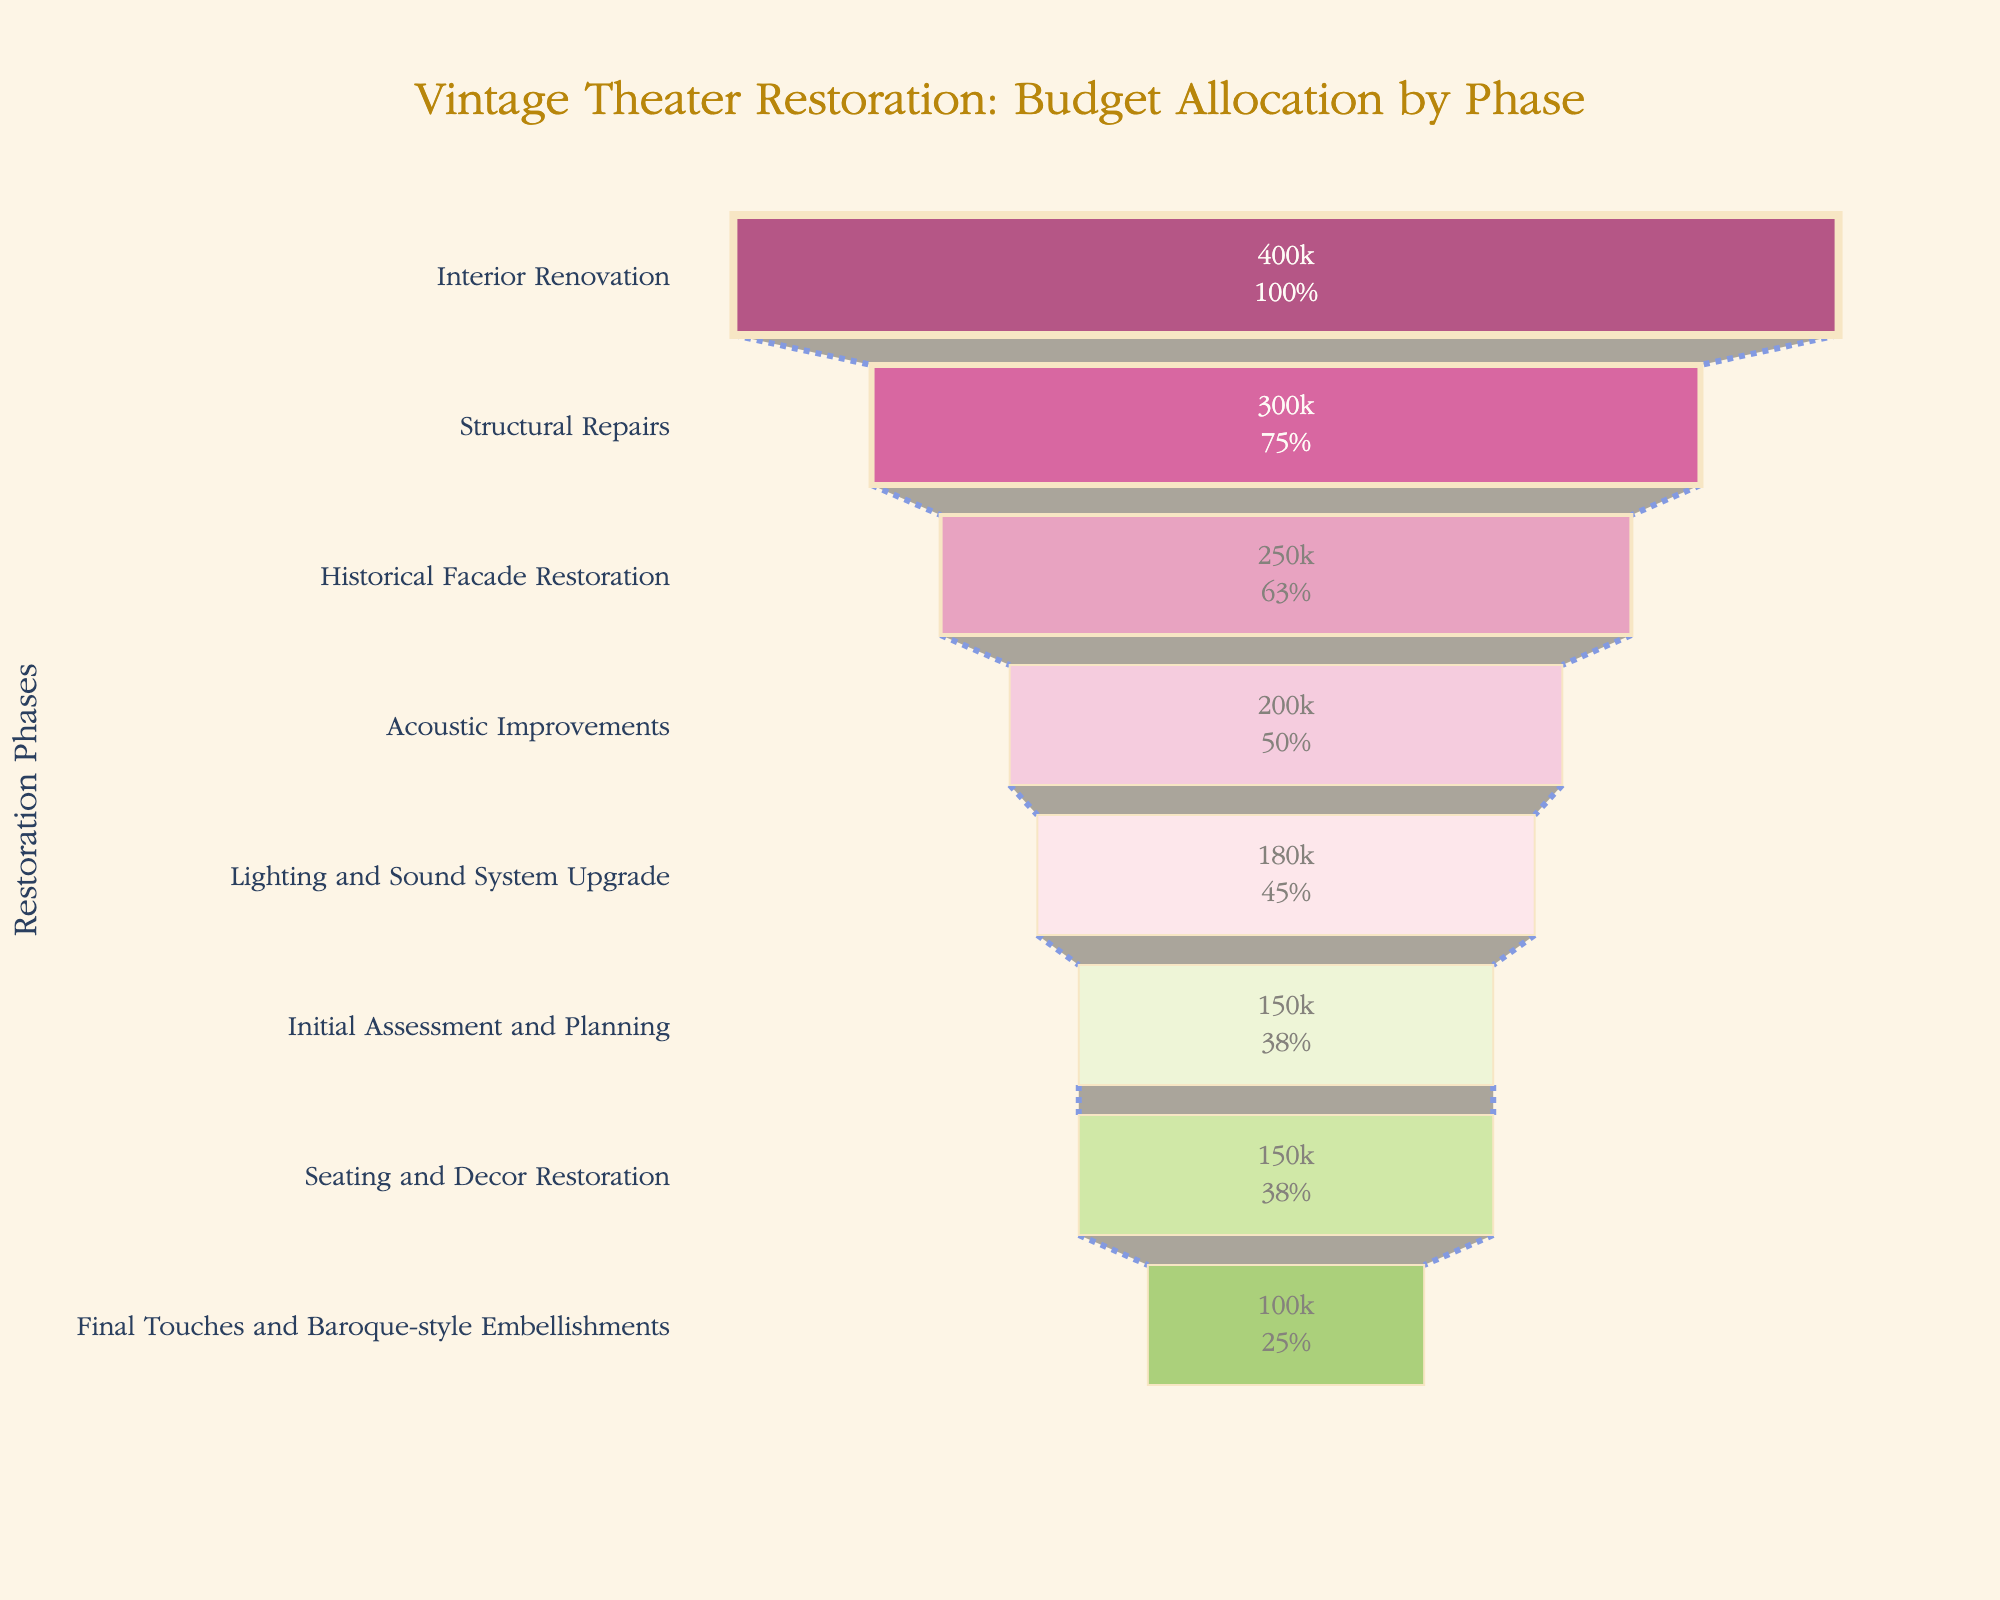What is the phase with the highest budget allocation? The phase with the highest budget allocation is the one with the largest section at the top of the funnel. In this case, "Interior Renovation" has the largest allocated budget.
Answer: Interior Renovation What is the total budget allocation for all phases combined? To find the total budget allocation, sum the values of each phase: 150,000 (Initial Assessment and Planning) + 300,000 (Structural Repairs) + 250,000 (Historical Facade Restoration) + 400,000 (Interior Renovation) + 200,000 (Acoustic Improvements) + 180,000 (Lighting and Sound System Upgrade) + 150,000 (Seating and Decor Restoration) + 100,000 (Final Touches and Baroque-style Embellishments) = 1,730,000.
Answer: 1,730,000 Which phases together require a budget exceeding half of the total budget? First, calculate half of the total budget: 1,730,000 / 2 = 865,000. Then add the phases starting from the largest until the sum exceeds 865,000. Interior Renovation (400,000) + Structural Repairs (300,000) + Historical Facade Restoration (250,000) = 950,000. These three phases exceed half of the total budget.
Answer: Interior Renovation, Structural Repairs, Historical Facade Restoration How does the budget allocation for Structural Repairs compare to that for Acoustic Improvements? Compare the allocated budgets for both phases: Structural Repairs (300,000) and Acoustic Improvements (200,000). 300,000 is greater than 200,000, so Structural Repairs has a higher allocation.
Answer: Structural Repairs has a higher allocation What percentage of the total budget is allocated to Lighting and Sound System Upgrade? To calculate the percentage, divide the budget for Lighting and Sound System Upgrade by the total budget and multiply by 100: (180,000 / 1,730,000) * 100 ≈ 10.40%.
Answer: Approximately 10.40% Which phase has the lowest budget allocation? The phase with the lowest budget allocation is the one with the smallest section at the bottom of the funnel. In this case, "Final Touches and Baroque-style Embellishments" has the lowest allocated budget.
Answer: Final Touches and Baroque-style Embellishments What is the combined budget of Historical Facade Restoration and Seating and Decor Restoration? Add the budget allocations for both phases: Historical Facade Restoration (250,000) + Seating and Decor Restoration (150,000) = 400,000.
Answer: 400,000 How many phases have a budget allocation of at least 200,000? Identify and count the phases with budgets of 200,000 or more: Structural Repairs (300,000), Historical Facade Restoration (250,000), Interior Renovation (400,000), Acoustic Improvements (200,000), and Lighting and Sound System Upgrade (180,000). There are 4 such phases.
Answer: 4 